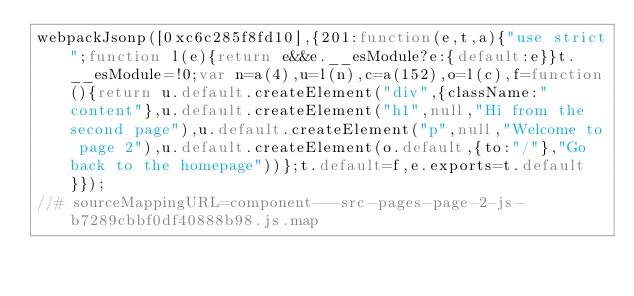Convert code to text. <code><loc_0><loc_0><loc_500><loc_500><_JavaScript_>webpackJsonp([0xc6c285f8fd10],{201:function(e,t,a){"use strict";function l(e){return e&&e.__esModule?e:{default:e}}t.__esModule=!0;var n=a(4),u=l(n),c=a(152),o=l(c),f=function(){return u.default.createElement("div",{className:"content"},u.default.createElement("h1",null,"Hi from the second page"),u.default.createElement("p",null,"Welcome to page 2"),u.default.createElement(o.default,{to:"/"},"Go back to the homepage"))};t.default=f,e.exports=t.default}});
//# sourceMappingURL=component---src-pages-page-2-js-b7289cbbf0df40888b98.js.map</code> 